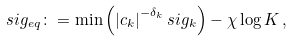<formula> <loc_0><loc_0><loc_500><loc_500>s i g _ { e q } \colon = \min \left ( \left | c _ { k } \right | ^ { - \delta _ { k } } s i g _ { k } \right ) - \chi \log K \, ,</formula> 